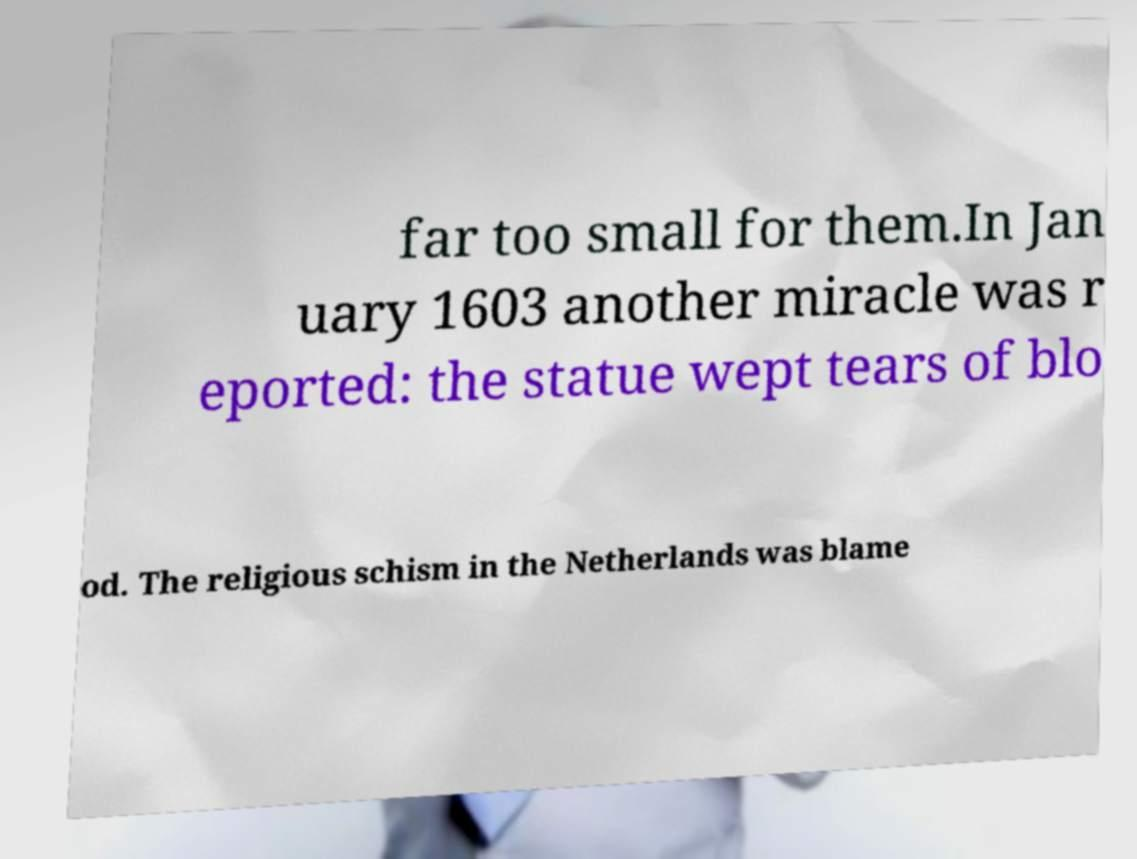Could you extract and type out the text from this image? far too small for them.In Jan uary 1603 another miracle was r eported: the statue wept tears of blo od. The religious schism in the Netherlands was blame 